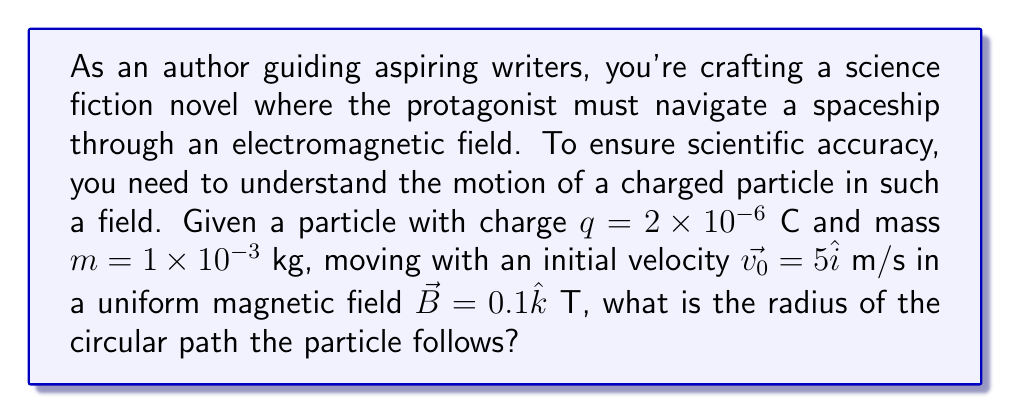Provide a solution to this math problem. Let's approach this step-by-step:

1) In a uniform magnetic field, a charged particle follows a circular path perpendicular to the field direction. The magnetic force provides the centripetal force for this circular motion.

2) The magnetic force is given by:
   $$\vec{F} = q(\vec{v} \times \vec{B})$$

3) The magnitude of this force is:
   $$F = qvB\sin\theta$$
   where $\theta$ is the angle between $\vec{v}$ and $\vec{B}$. In this case, $\theta = 90°$, so $\sin\theta = 1$.

4) This force acts as the centripetal force:
   $$F = \frac{mv^2}{r}$$

5) Equating these:
   $$qvB = \frac{mv^2}{r}$$

6) Solving for r:
   $$r = \frac{mv}{qB}$$

7) Substituting the given values:
   $$r = \frac{(1\times10^{-3})(5)}{(2\times10^{-6})(0.1)}$$

8) Calculating:
   $$r = \frac{5\times10^{-3}}{2\times10^{-7}} = 2.5\times10^4\text{ m}$$
Answer: $2.5\times10^4$ m 